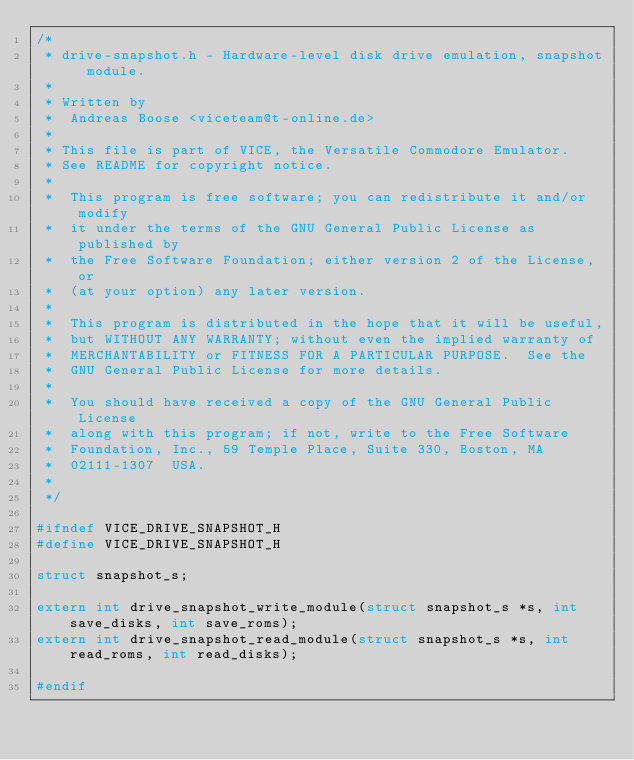Convert code to text. <code><loc_0><loc_0><loc_500><loc_500><_C_>/*
 * drive-snapshot.h - Hardware-level disk drive emulation, snapshot module.
 *
 * Written by
 *  Andreas Boose <viceteam@t-online.de>
 *
 * This file is part of VICE, the Versatile Commodore Emulator.
 * See README for copyright notice.
 *
 *  This program is free software; you can redistribute it and/or modify
 *  it under the terms of the GNU General Public License as published by
 *  the Free Software Foundation; either version 2 of the License, or
 *  (at your option) any later version.
 *
 *  This program is distributed in the hope that it will be useful,
 *  but WITHOUT ANY WARRANTY; without even the implied warranty of
 *  MERCHANTABILITY or FITNESS FOR A PARTICULAR PURPOSE.  See the
 *  GNU General Public License for more details.
 *
 *  You should have received a copy of the GNU General Public License
 *  along with this program; if not, write to the Free Software
 *  Foundation, Inc., 59 Temple Place, Suite 330, Boston, MA
 *  02111-1307  USA.
 *
 */

#ifndef VICE_DRIVE_SNAPSHOT_H
#define VICE_DRIVE_SNAPSHOT_H

struct snapshot_s;

extern int drive_snapshot_write_module(struct snapshot_s *s, int save_disks, int save_roms);
extern int drive_snapshot_read_module(struct snapshot_s *s, int read_roms, int read_disks);

#endif
</code> 